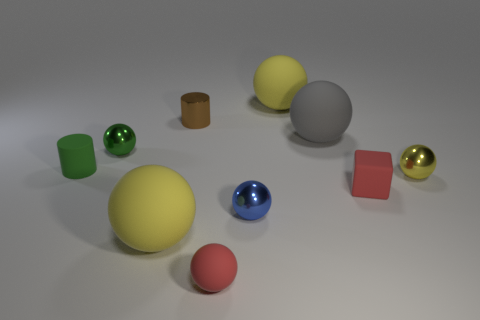Subtract all tiny red balls. How many balls are left? 6 Subtract all red balls. How many balls are left? 6 Subtract all yellow cylinders. How many yellow balls are left? 3 Subtract 3 balls. How many balls are left? 4 Subtract all cyan balls. Subtract all yellow cylinders. How many balls are left? 7 Subtract all blocks. How many objects are left? 9 Add 2 cyan matte cylinders. How many cyan matte cylinders exist? 2 Subtract 0 purple spheres. How many objects are left? 10 Subtract all green cylinders. Subtract all blue spheres. How many objects are left? 8 Add 4 large things. How many large things are left? 7 